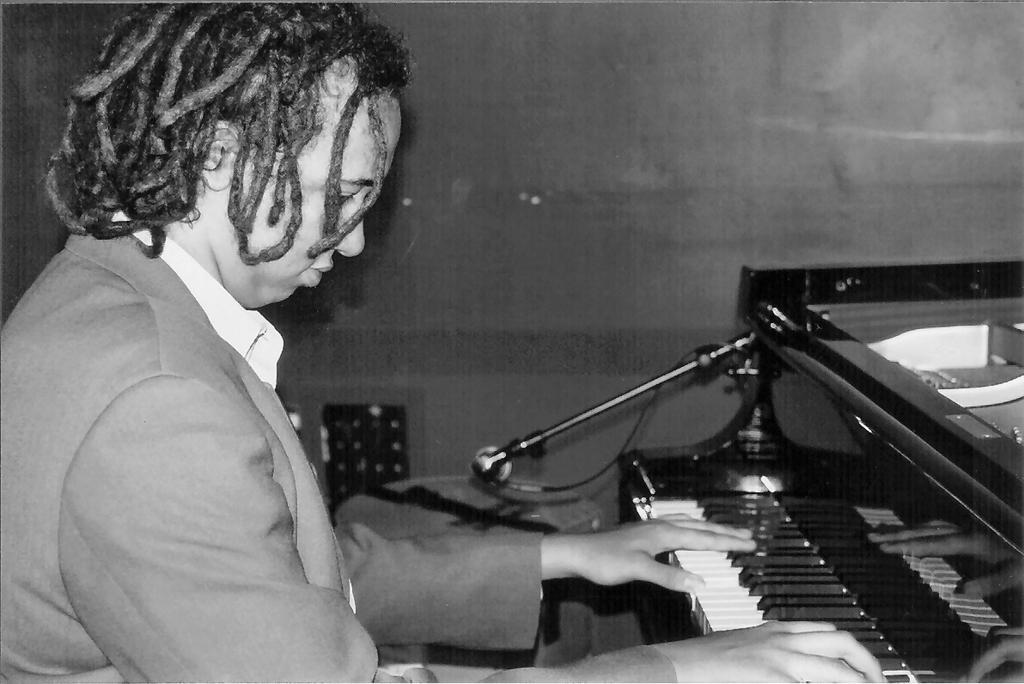Please provide a concise description of this image. In this image, In the let side there is a man sitting and he is playing a piano which is in black color, There is a microphone on the piano, In the background there is a black color wall. 